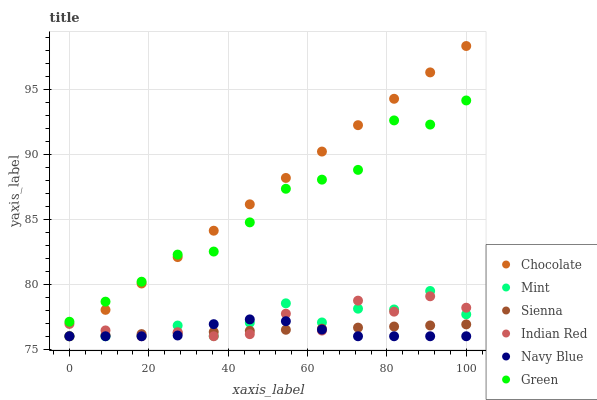Does Navy Blue have the minimum area under the curve?
Answer yes or no. Yes. Does Chocolate have the maximum area under the curve?
Answer yes or no. Yes. Does Sienna have the minimum area under the curve?
Answer yes or no. No. Does Sienna have the maximum area under the curve?
Answer yes or no. No. Is Chocolate the smoothest?
Answer yes or no. Yes. Is Indian Red the roughest?
Answer yes or no. Yes. Is Sienna the smoothest?
Answer yes or no. No. Is Sienna the roughest?
Answer yes or no. No. Does Navy Blue have the lowest value?
Answer yes or no. Yes. Does Green have the lowest value?
Answer yes or no. No. Does Chocolate have the highest value?
Answer yes or no. Yes. Does Sienna have the highest value?
Answer yes or no. No. Is Indian Red less than Green?
Answer yes or no. Yes. Is Green greater than Navy Blue?
Answer yes or no. Yes. Does Sienna intersect Navy Blue?
Answer yes or no. Yes. Is Sienna less than Navy Blue?
Answer yes or no. No. Is Sienna greater than Navy Blue?
Answer yes or no. No. Does Indian Red intersect Green?
Answer yes or no. No. 